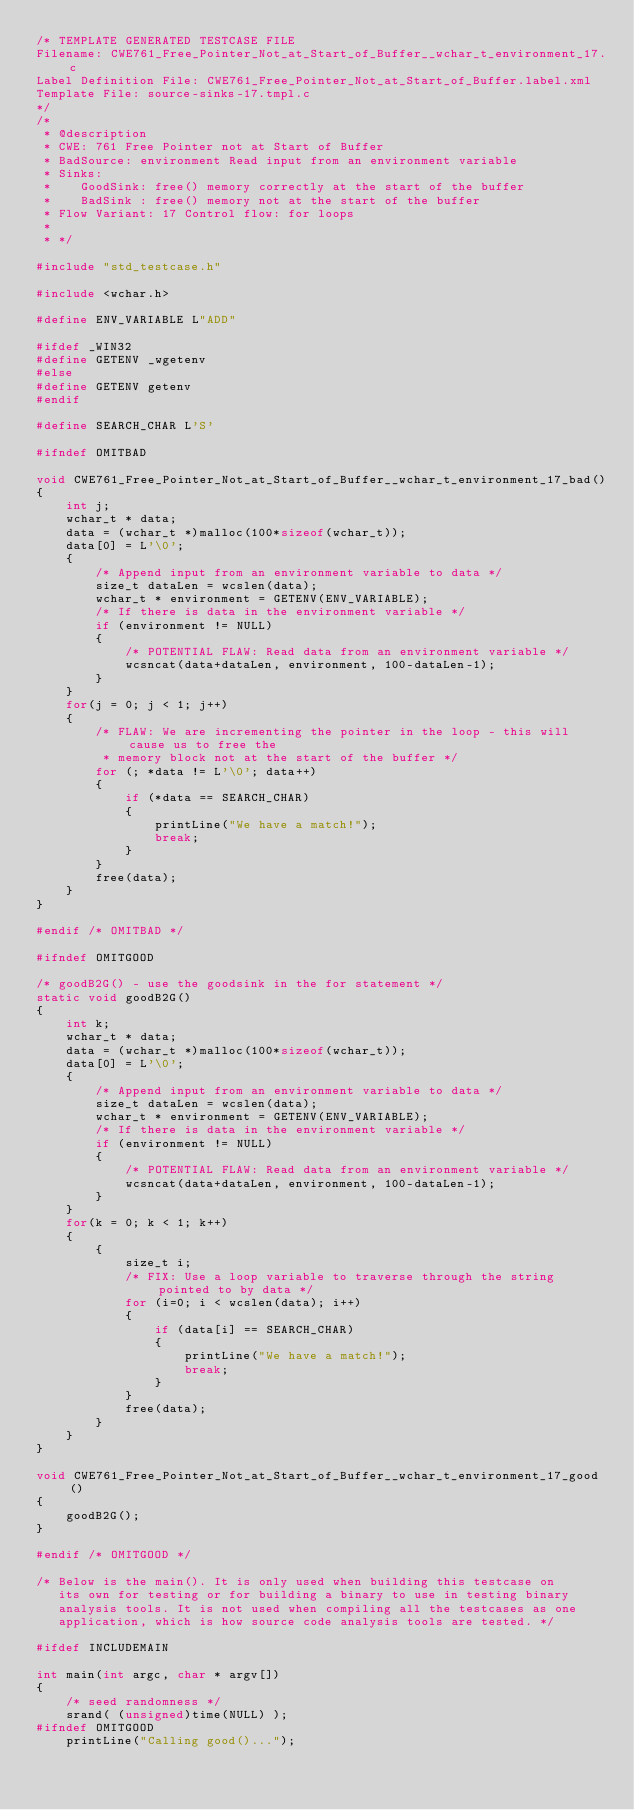Convert code to text. <code><loc_0><loc_0><loc_500><loc_500><_C_>/* TEMPLATE GENERATED TESTCASE FILE
Filename: CWE761_Free_Pointer_Not_at_Start_of_Buffer__wchar_t_environment_17.c
Label Definition File: CWE761_Free_Pointer_Not_at_Start_of_Buffer.label.xml
Template File: source-sinks-17.tmpl.c
*/
/*
 * @description
 * CWE: 761 Free Pointer not at Start of Buffer
 * BadSource: environment Read input from an environment variable
 * Sinks:
 *    GoodSink: free() memory correctly at the start of the buffer
 *    BadSink : free() memory not at the start of the buffer
 * Flow Variant: 17 Control flow: for loops
 *
 * */

#include "std_testcase.h"

#include <wchar.h>

#define ENV_VARIABLE L"ADD"

#ifdef _WIN32
#define GETENV _wgetenv
#else
#define GETENV getenv
#endif

#define SEARCH_CHAR L'S'

#ifndef OMITBAD

void CWE761_Free_Pointer_Not_at_Start_of_Buffer__wchar_t_environment_17_bad()
{
    int j;
    wchar_t * data;
    data = (wchar_t *)malloc(100*sizeof(wchar_t));
    data[0] = L'\0';
    {
        /* Append input from an environment variable to data */
        size_t dataLen = wcslen(data);
        wchar_t * environment = GETENV(ENV_VARIABLE);
        /* If there is data in the environment variable */
        if (environment != NULL)
        {
            /* POTENTIAL FLAW: Read data from an environment variable */
            wcsncat(data+dataLen, environment, 100-dataLen-1);
        }
    }
    for(j = 0; j < 1; j++)
    {
        /* FLAW: We are incrementing the pointer in the loop - this will cause us to free the
         * memory block not at the start of the buffer */
        for (; *data != L'\0'; data++)
        {
            if (*data == SEARCH_CHAR)
            {
                printLine("We have a match!");
                break;
            }
        }
        free(data);
    }
}

#endif /* OMITBAD */

#ifndef OMITGOOD

/* goodB2G() - use the goodsink in the for statement */
static void goodB2G()
{
    int k;
    wchar_t * data;
    data = (wchar_t *)malloc(100*sizeof(wchar_t));
    data[0] = L'\0';
    {
        /* Append input from an environment variable to data */
        size_t dataLen = wcslen(data);
        wchar_t * environment = GETENV(ENV_VARIABLE);
        /* If there is data in the environment variable */
        if (environment != NULL)
        {
            /* POTENTIAL FLAW: Read data from an environment variable */
            wcsncat(data+dataLen, environment, 100-dataLen-1);
        }
    }
    for(k = 0; k < 1; k++)
    {
        {
            size_t i;
            /* FIX: Use a loop variable to traverse through the string pointed to by data */
            for (i=0; i < wcslen(data); i++)
            {
                if (data[i] == SEARCH_CHAR)
                {
                    printLine("We have a match!");
                    break;
                }
            }
            free(data);
        }
    }
}

void CWE761_Free_Pointer_Not_at_Start_of_Buffer__wchar_t_environment_17_good()
{
    goodB2G();
}

#endif /* OMITGOOD */

/* Below is the main(). It is only used when building this testcase on
   its own for testing or for building a binary to use in testing binary
   analysis tools. It is not used when compiling all the testcases as one
   application, which is how source code analysis tools are tested. */

#ifdef INCLUDEMAIN

int main(int argc, char * argv[])
{
    /* seed randomness */
    srand( (unsigned)time(NULL) );
#ifndef OMITGOOD
    printLine("Calling good()...");</code> 